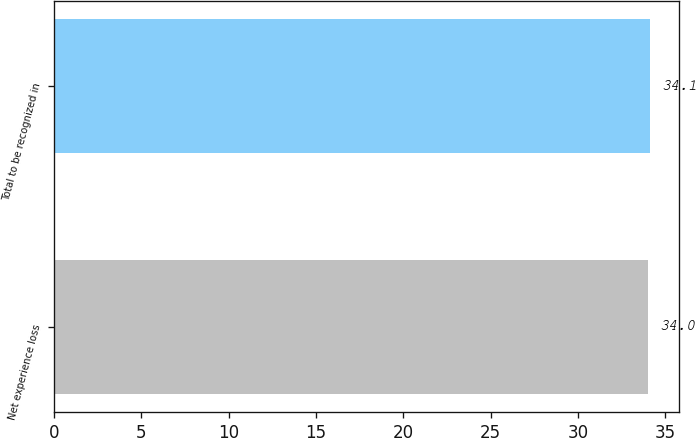Convert chart. <chart><loc_0><loc_0><loc_500><loc_500><bar_chart><fcel>Net experience loss<fcel>Total to be recognized in<nl><fcel>34<fcel>34.1<nl></chart> 